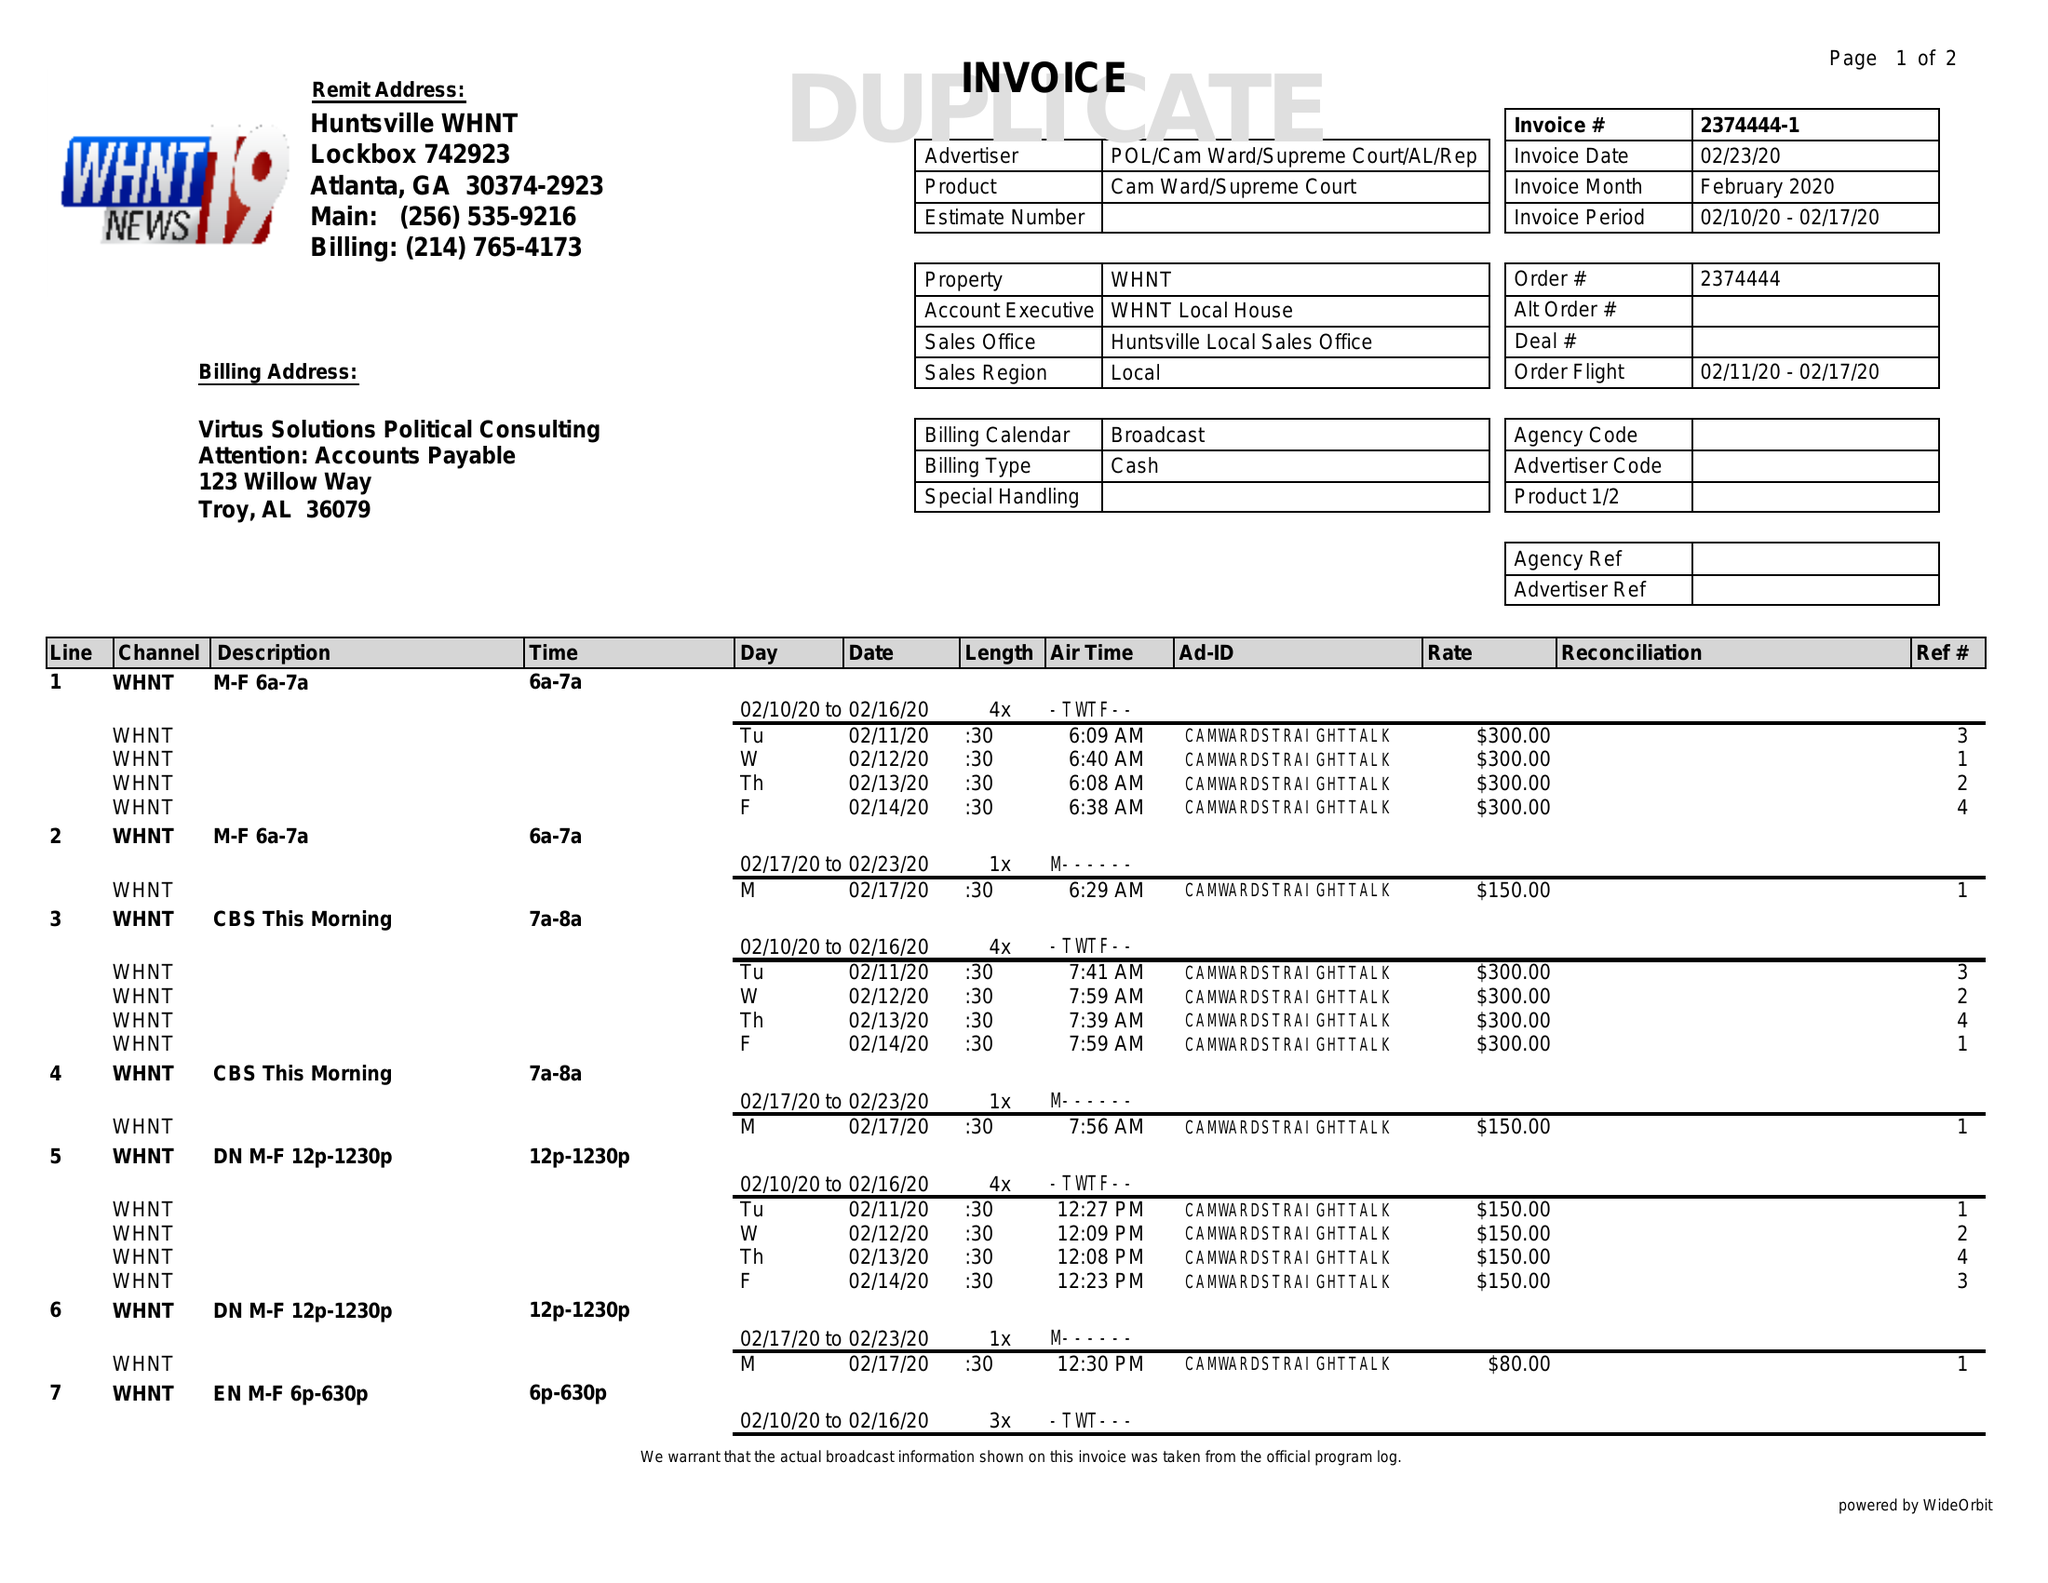What is the value for the contract_num?
Answer the question using a single word or phrase. 2374444 